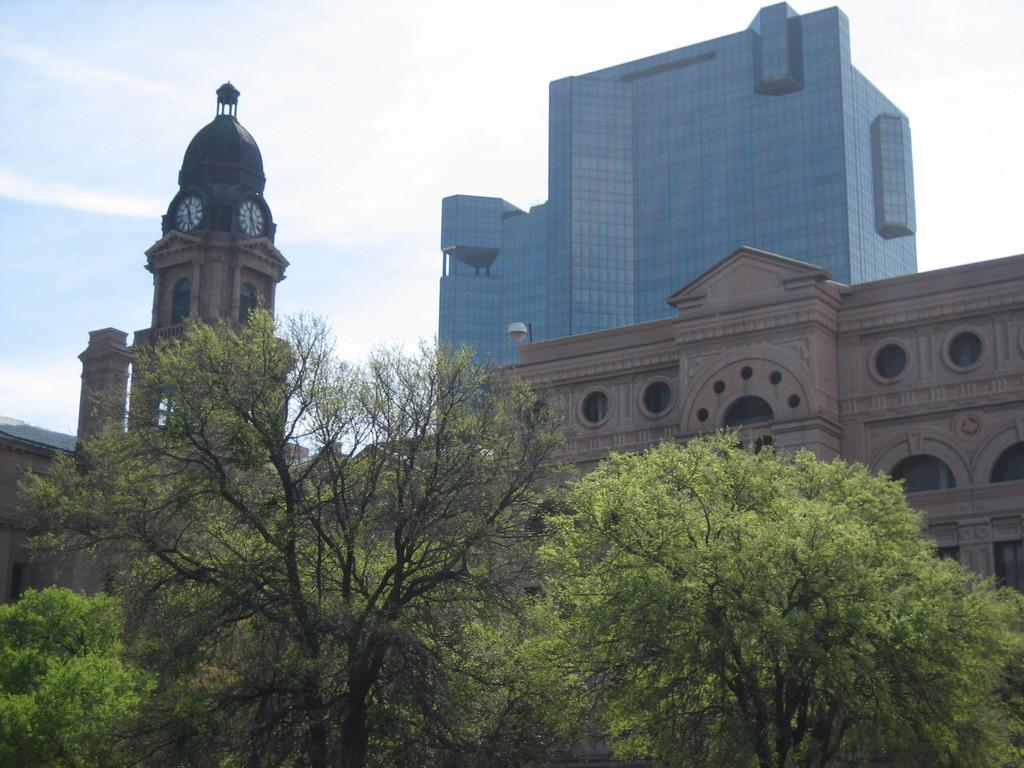What type of natural elements can be seen in the image? There are trees in the image. What man-made objects are present in the image? There are clocks and buildings in the image. What can be seen in the background of the image? The sky is visible in the background of the image, and what else can be observed? How many jellyfish are swimming in the sky in the image? There are no jellyfish present in the image; it features trees, clocks, buildings, and clouds in the sky. What country is depicted in the image? The image does not depict a specific country; it shows a general scene with trees, clocks, buildings, and clouds in the sky. 